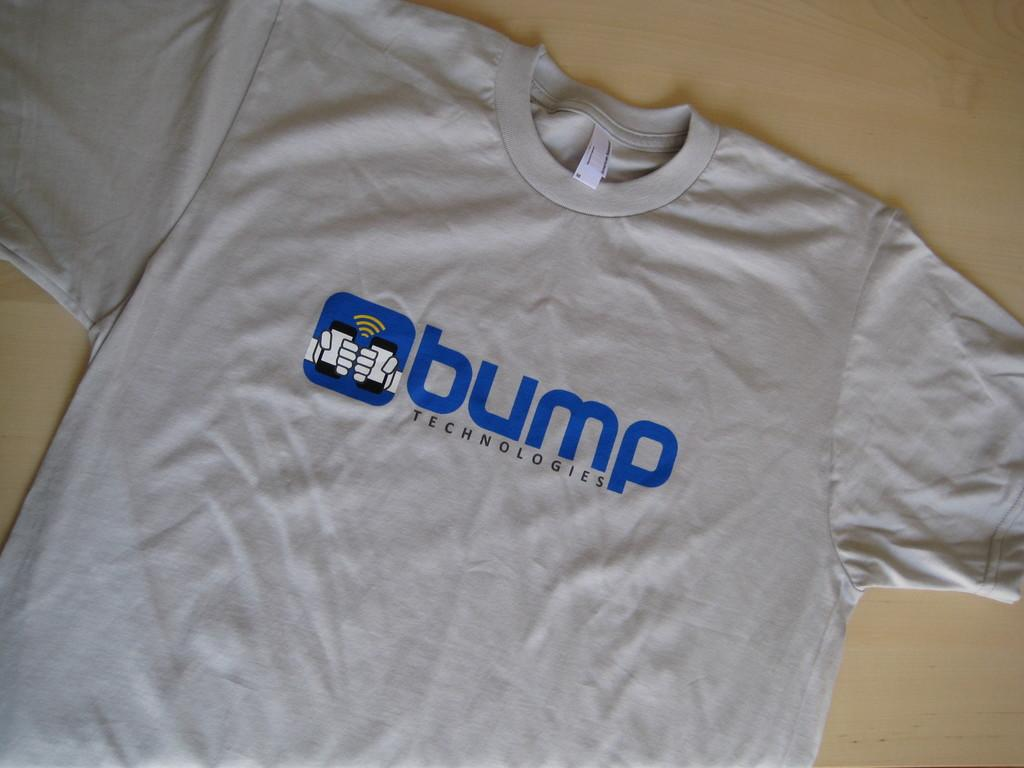<image>
Create a compact narrative representing the image presented. A white shirt that says "bump" lays flat on a table 